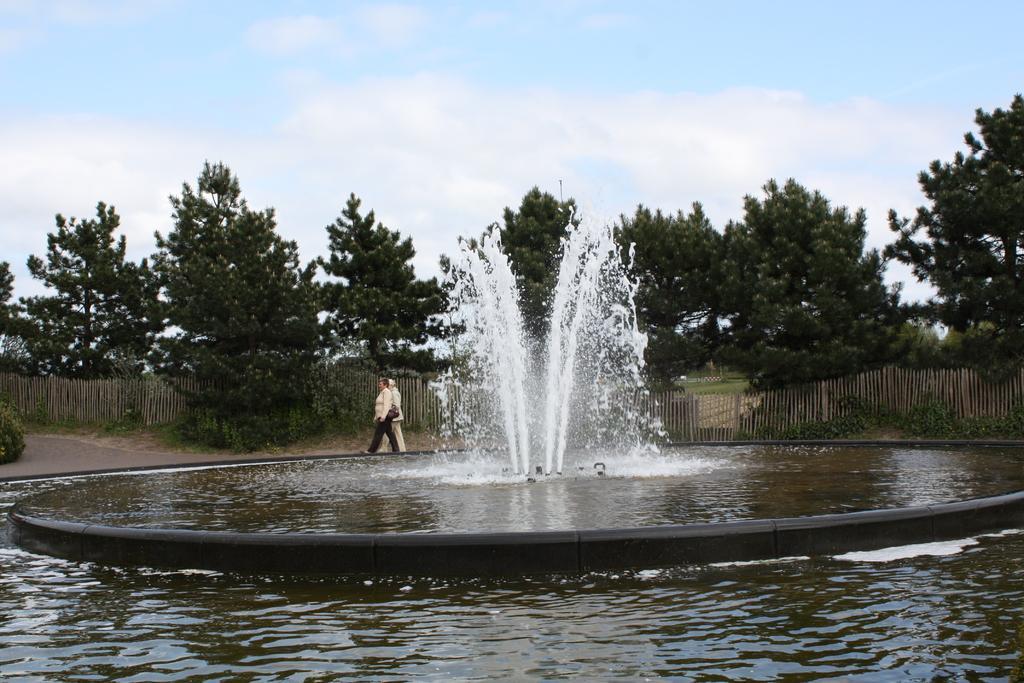Please provide a concise description of this image. This is an outside view. At the bottom there is a fountain. Beside two persons are walking on the road towards the left side. In the background there is a railing and many trees. At the top of the image I can see the sky and clouds. 